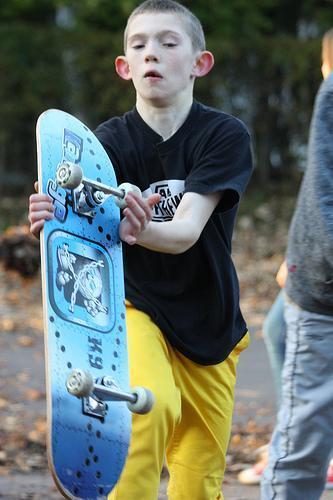How many skateboards are in the photo?
Give a very brief answer. 1. 